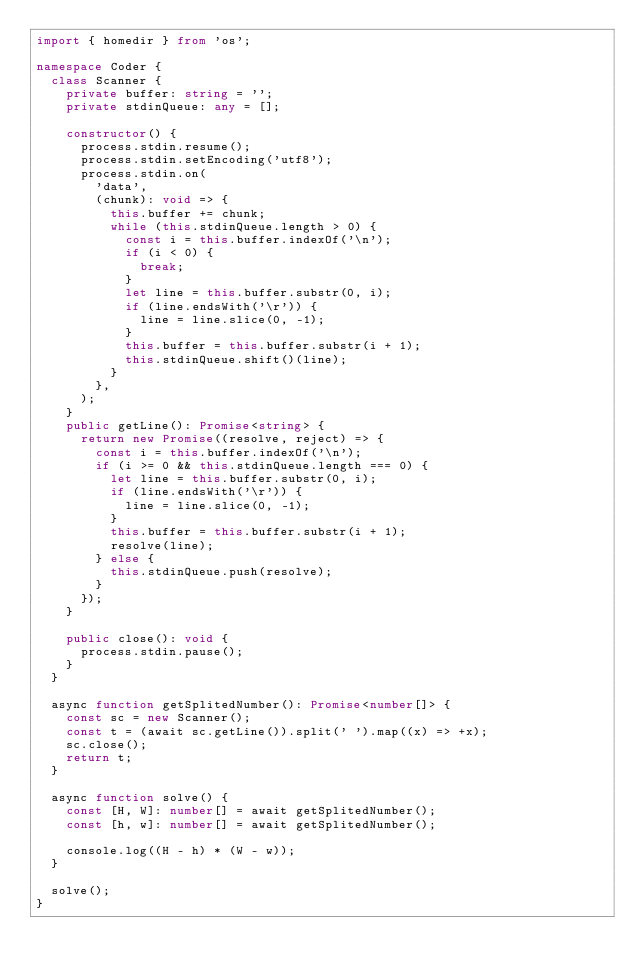Convert code to text. <code><loc_0><loc_0><loc_500><loc_500><_TypeScript_>import { homedir } from 'os';

namespace Coder {
  class Scanner {
    private buffer: string = '';
    private stdinQueue: any = [];

    constructor() {
      process.stdin.resume();
      process.stdin.setEncoding('utf8');
      process.stdin.on(
        'data',
        (chunk): void => {
          this.buffer += chunk;
          while (this.stdinQueue.length > 0) {
            const i = this.buffer.indexOf('\n');
            if (i < 0) {
              break;
            }
            let line = this.buffer.substr(0, i);
            if (line.endsWith('\r')) {
              line = line.slice(0, -1);
            }
            this.buffer = this.buffer.substr(i + 1);
            this.stdinQueue.shift()(line);
          }
        },
      );
    }
    public getLine(): Promise<string> {
      return new Promise((resolve, reject) => {
        const i = this.buffer.indexOf('\n');
        if (i >= 0 && this.stdinQueue.length === 0) {
          let line = this.buffer.substr(0, i);
          if (line.endsWith('\r')) {
            line = line.slice(0, -1);
          }
          this.buffer = this.buffer.substr(i + 1);
          resolve(line);
        } else {
          this.stdinQueue.push(resolve);
        }
      });
    }

    public close(): void {
      process.stdin.pause();
    }
  }

  async function getSplitedNumber(): Promise<number[]> {
    const sc = new Scanner();
    const t = (await sc.getLine()).split(' ').map((x) => +x);
    sc.close();
    return t;
  }

  async function solve() {
    const [H, W]: number[] = await getSplitedNumber();
    const [h, w]: number[] = await getSplitedNumber();

    console.log((H - h) * (W - w));
  }

  solve();
}
</code> 